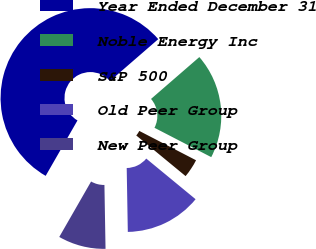Convert chart to OTSL. <chart><loc_0><loc_0><loc_500><loc_500><pie_chart><fcel>Year Ended December 31<fcel>Noble Energy Inc<fcel>S&P 500<fcel>Old Peer Group<fcel>New Peer Group<nl><fcel>55.34%<fcel>18.96%<fcel>3.37%<fcel>13.76%<fcel>8.57%<nl></chart> 